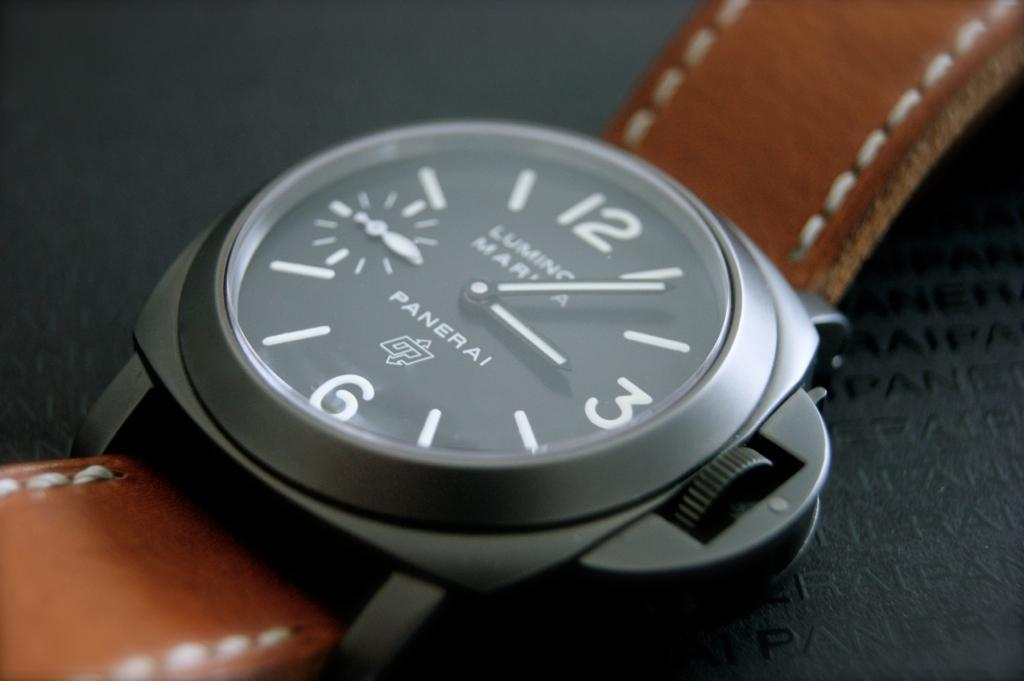<image>
Create a compact narrative representing the image presented. A Panerai watch has the time at about 3:06. 